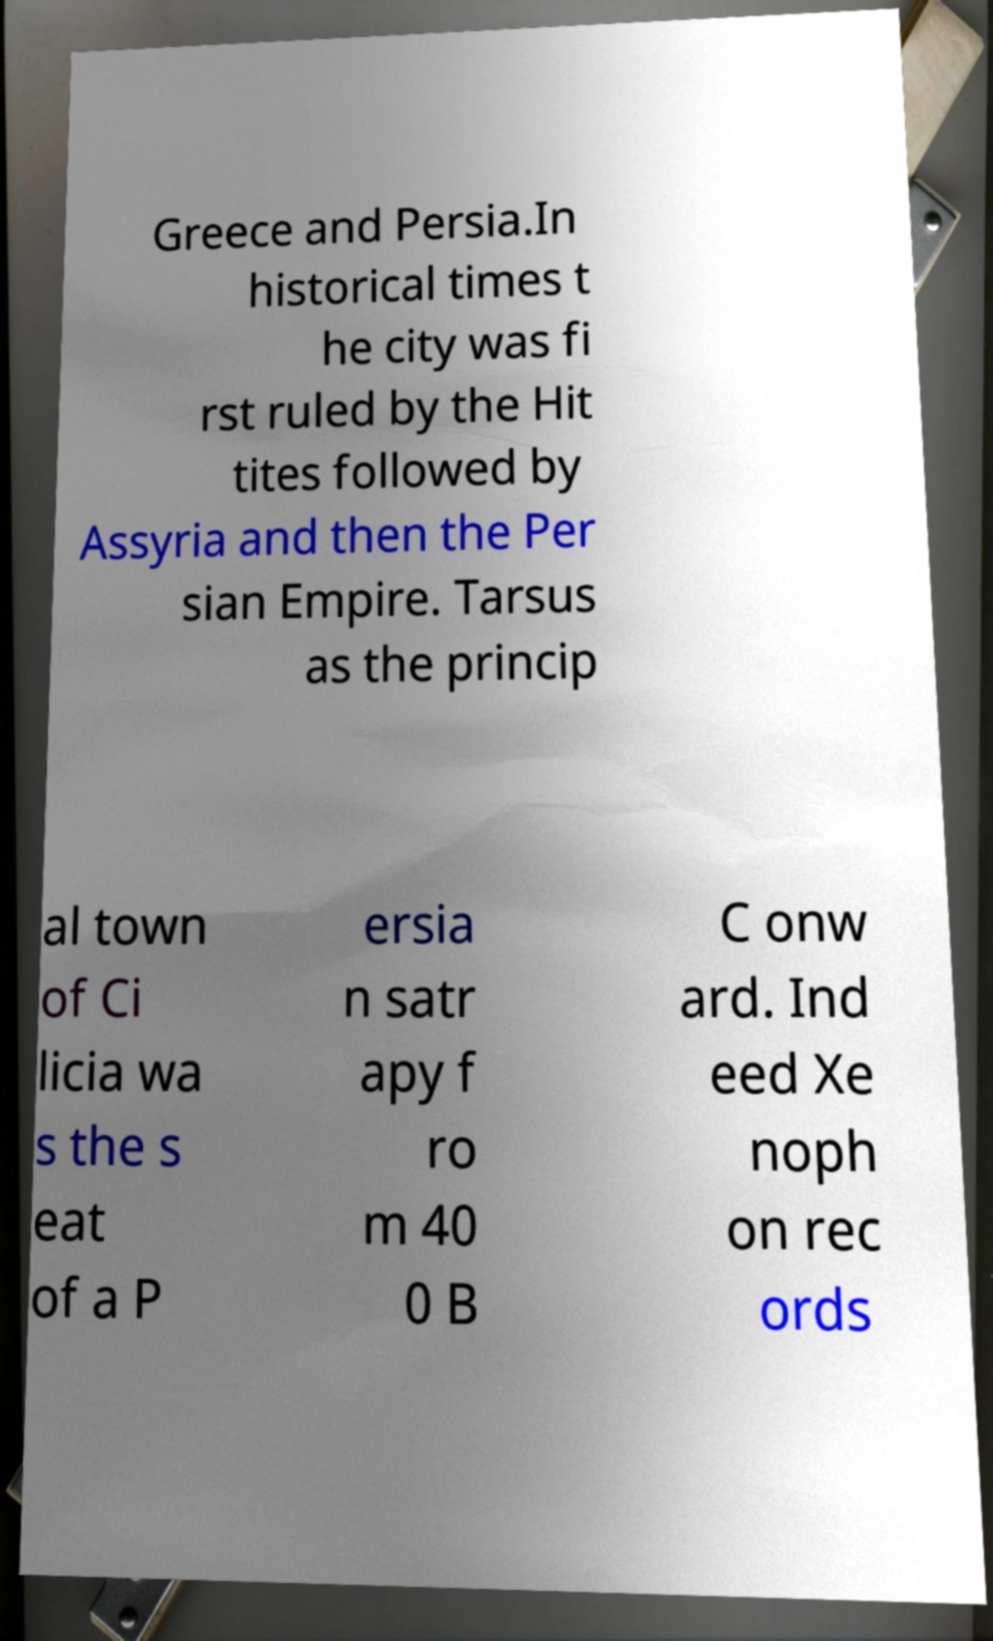Can you accurately transcribe the text from the provided image for me? Greece and Persia.In historical times t he city was fi rst ruled by the Hit tites followed by Assyria and then the Per sian Empire. Tarsus as the princip al town of Ci licia wa s the s eat of a P ersia n satr apy f ro m 40 0 B C onw ard. Ind eed Xe noph on rec ords 